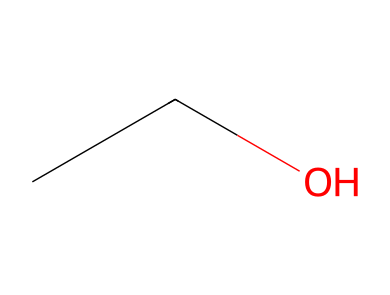What is the molecular formula of this solvent? The SMILES representation "CCO" indicates there are two carbon atoms (C), six hydrogen atoms (H), and one oxygen atom (O), which together form the molecular formula of ethanol.
Answer: C2H6O How many carbon atoms are present in this structure? Looking at the SMILES representation "CCO," we see there are two "C" characters, indicating there are two carbon atoms in the molecule.
Answer: 2 What type of functional group is present in ethanol? The structure shows an alcohol functionality due to the presence of the -OH group connected to the carbon chain.
Answer: alcohol Is ethanol more polar or nonpolar? The presence of an -OH group indicates that ethyl alcohol has considerable polarity, as the oxygen atom has a higher electronegativity compared to carbon and hydrogen, allowing for hydrogen bonding.
Answer: polar What is the total number of hydrogen bonds possible with ethanol? Ethanol can form up to three hydrogen bonds: one from the hydroxyl group and potential interactions due to the presence of additional hydrogen atoms on the carbon chain.
Answer: 3 How would you categorize ethanol in terms of its solubility in water? Given its polar nature due to the -OH group, ethanol is soluble in water, which is also a polar solvent, leading to strong interactions between the two.
Answer: soluble What is the primary use of ethanol as a solvent? Ethanol is primarily used as a solvent for various chemical reactions, particularly in laboratory settings due to its ability to dissolve a wide range of substances.
Answer: solvent 